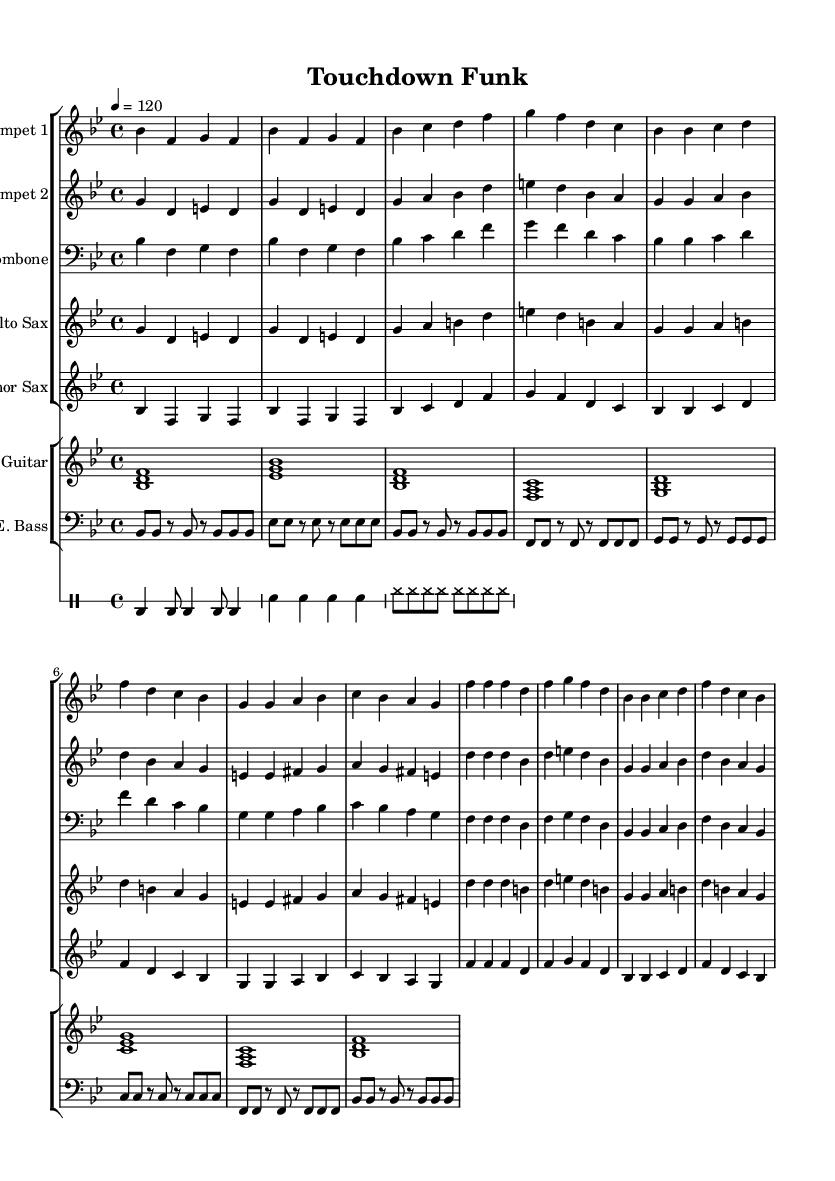What is the key signature of this music? The key signature is indicated at the start of the sheet music and shows two flats (B♭ and E♭), meaning it is in B♭ major.
Answer: B♭ major What is the time signature of this music? The time signature is found at the beginning of the music, showing a 4 over 4, which means there are four beats in each measure and the quarter note receives one beat.
Answer: 4/4 What is the tempo indication for the piece? The tempo is presented in beats per minute at the start, which says "4 = 120", indicating that the quarter note should be played at 120 beats per minute.
Answer: 120 How many measures does the trumpet part contain? By counting the measures in the trumpet part, we can see that there are a total of 8 measures in this excerpt of the Trumpet 1 music.
Answer: 8 What instruments are featured in this composition? The sheet music lists a total of six instruments: Trumpet 1, Trumpet 2, Trombone, Alto Sax, Tenor Sax, Electric Guitar, and Electric Bass.
Answer: Trumpet 1, Trumpet 2, Trombone, Alto Sax, Tenor Sax, Electric Guitar, Electric Bass Which sections make up the rhythm section in this piece? The rhythm section is made up of the Electric Guitar and Electric Bass, as these instruments typically provide the harmonic and rhythmic foundation in Funk music.
Answer: Electric Guitar, Electric Bass What genre of music is this composition aligned with? The musical elements present, such as the use of brass, energetic rhythms, and syncopation, are characteristic of Funk music, which emphasizes groove and rhythm.
Answer: Funk 